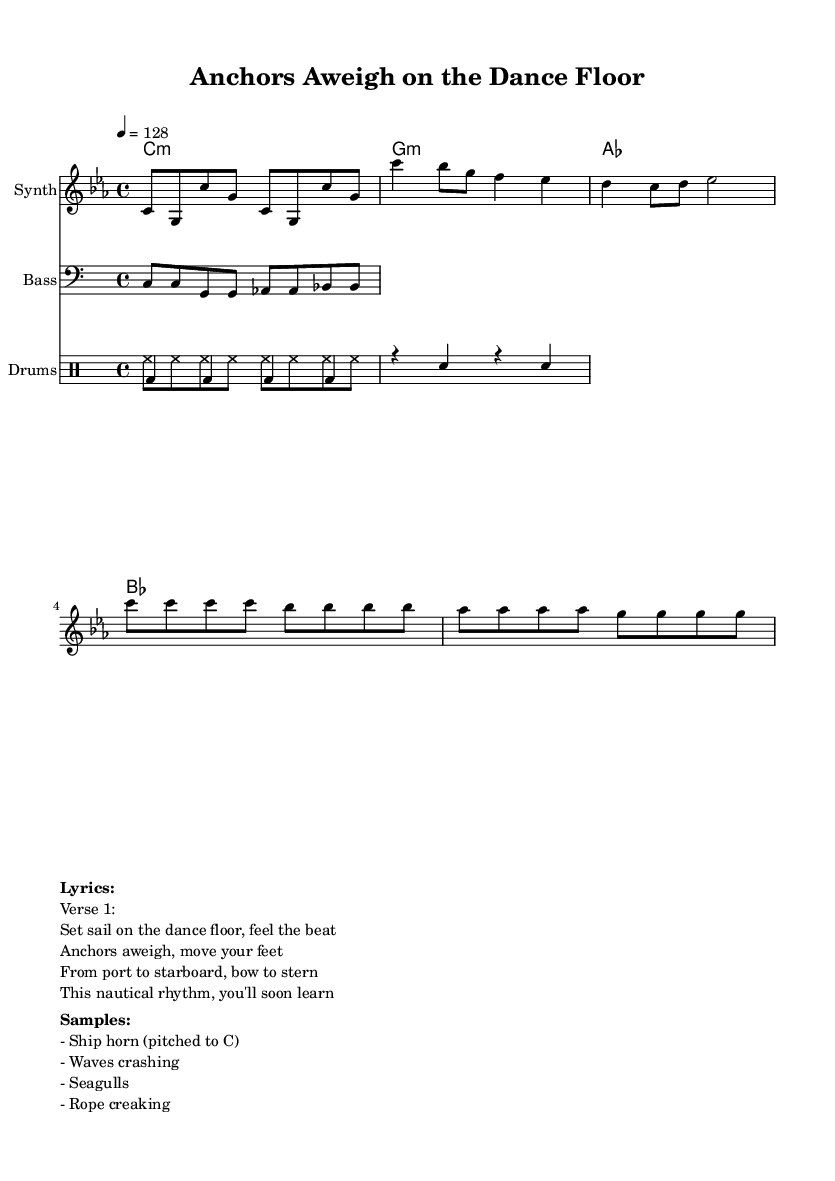What is the key signature of this music? The key signature indicated in the score is C minor, which contains three flats (B♭, E♭, A♭).
Answer: C minor What is the time signature of this music? The time signature displayed in the sheet music is 4/4, indicating four beats per measure.
Answer: 4/4 What is the tempo marking of the piece? The tempo marking is indicated as 4 = 128, meaning the quarter note gets a beat of 128 beats per minute.
Answer: 128 How many measures are in the intro section? The intro section consists of 8 eighth notes organized into 4 measures, as it is structured in 4/4 time.
Answer: 4 Which instrument plays the melody? The melody is played by the instrument labeled as "Synth" in the score.
Answer: Synth What musical term describes the drop in the piece? The drop section features a repeated pattern primarily using a rise in pitch followed by a drop, which is a common element in dance music.
Answer: Drop What type of sounds are included as samples in the sheet music? The listed samples include sounds that evoke a nautical theme, such as a ship horn, waves crashing, seagulls, and rope creaking.
Answer: Nautical sounds 